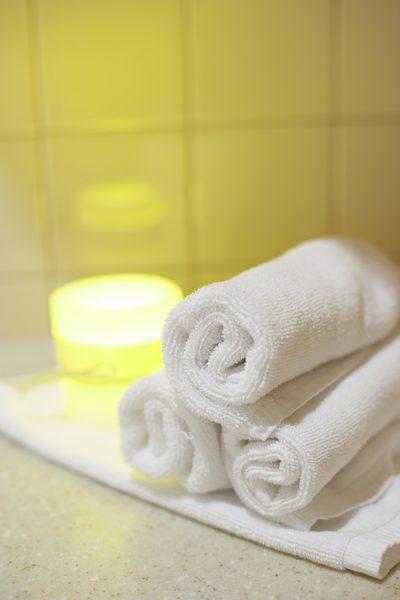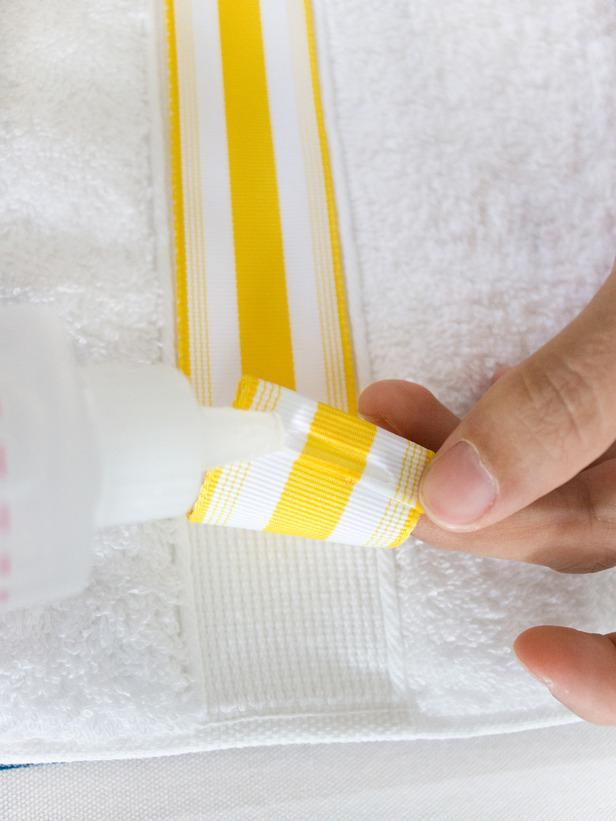The first image is the image on the left, the second image is the image on the right. Evaluate the accuracy of this statement regarding the images: "There is a white towel with a yellow and white band down the center in the image on the right.". Is it true? Answer yes or no. Yes. The first image is the image on the left, the second image is the image on the right. Given the left and right images, does the statement "In the right image, there is a white towel with a white and yellow striped strip of ribbon" hold true? Answer yes or no. Yes. 